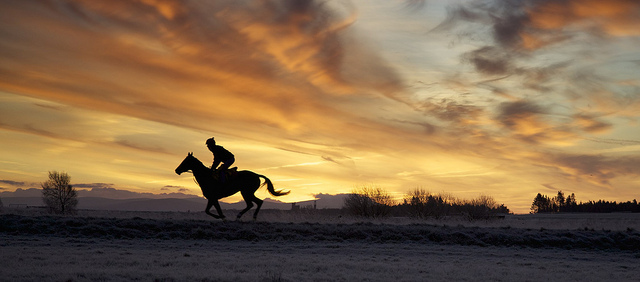What season does the environment in the photo suggest? The environment suggests it could be late autumn or winter, evidenced by the absence of leaves on the trees and the frosty look of the ground, indicative of the cooler seasons. 